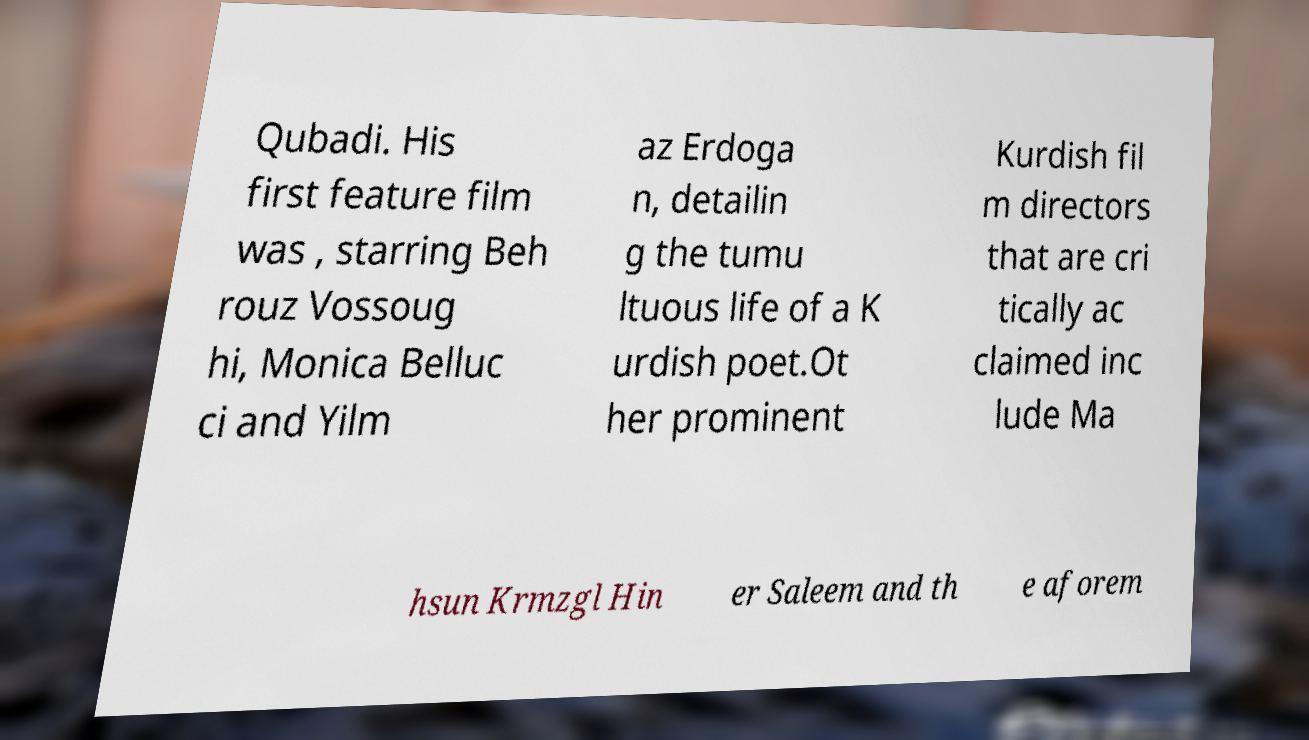Could you assist in decoding the text presented in this image and type it out clearly? Qubadi. His first feature film was , starring Beh rouz Vossoug hi, Monica Belluc ci and Yilm az Erdoga n, detailin g the tumu ltuous life of a K urdish poet.Ot her prominent Kurdish fil m directors that are cri tically ac claimed inc lude Ma hsun Krmzgl Hin er Saleem and th e aforem 